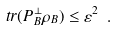Convert formula to latex. <formula><loc_0><loc_0><loc_500><loc_500>\ t r ( P _ { B } ^ { \bot } \rho _ { B } ) \leq \varepsilon ^ { 2 } \ .</formula> 